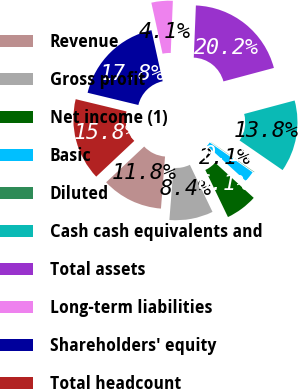Convert chart to OTSL. <chart><loc_0><loc_0><loc_500><loc_500><pie_chart><fcel>Revenue<fcel>Gross profit<fcel>Net income (1)<fcel>Basic<fcel>Diluted<fcel>Cash cash equivalents and<fcel>Total assets<fcel>Long-term liabilities<fcel>Shareholders' equity<fcel>Total headcount<nl><fcel>11.75%<fcel>8.38%<fcel>6.11%<fcel>2.08%<fcel>0.07%<fcel>13.76%<fcel>20.2%<fcel>4.09%<fcel>17.79%<fcel>15.77%<nl></chart> 